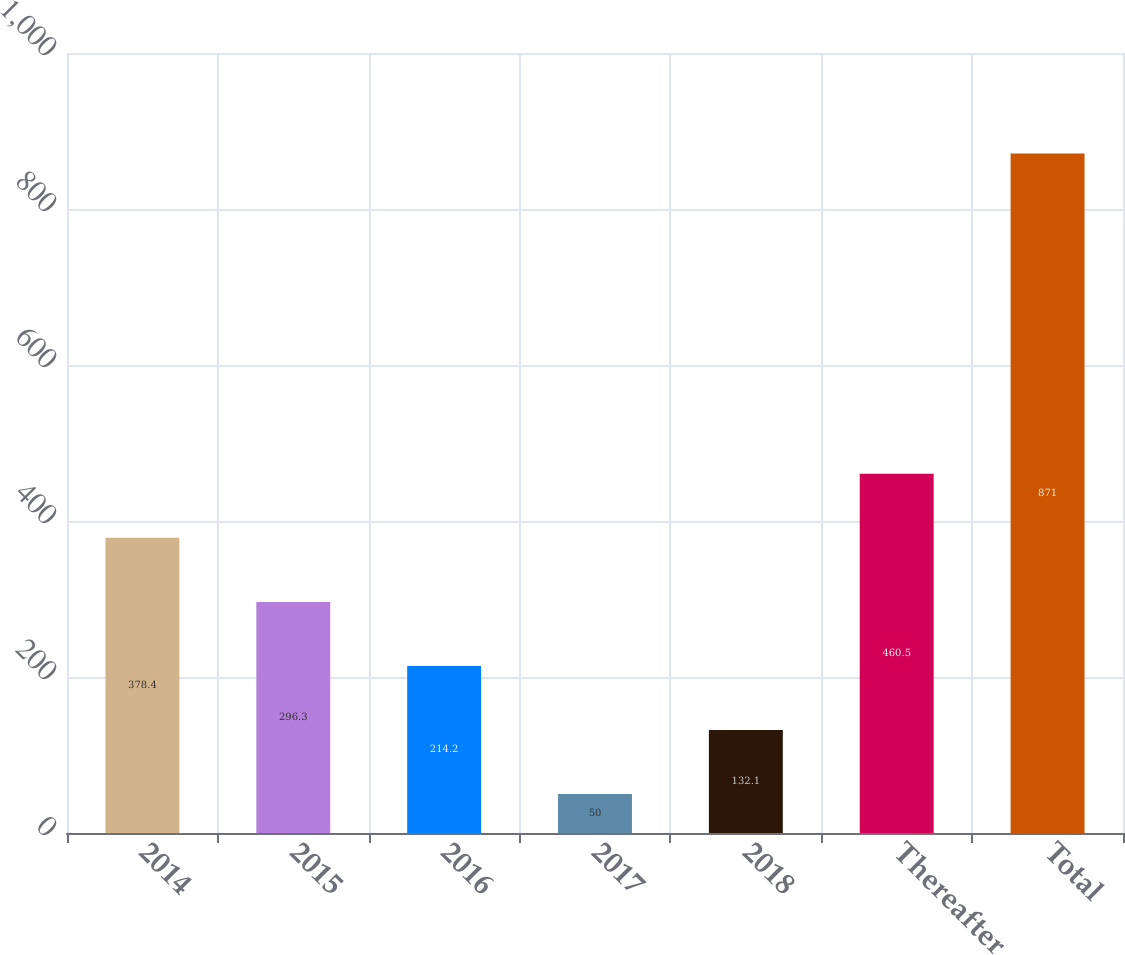Convert chart to OTSL. <chart><loc_0><loc_0><loc_500><loc_500><bar_chart><fcel>2014<fcel>2015<fcel>2016<fcel>2017<fcel>2018<fcel>Thereafter<fcel>Total<nl><fcel>378.4<fcel>296.3<fcel>214.2<fcel>50<fcel>132.1<fcel>460.5<fcel>871<nl></chart> 